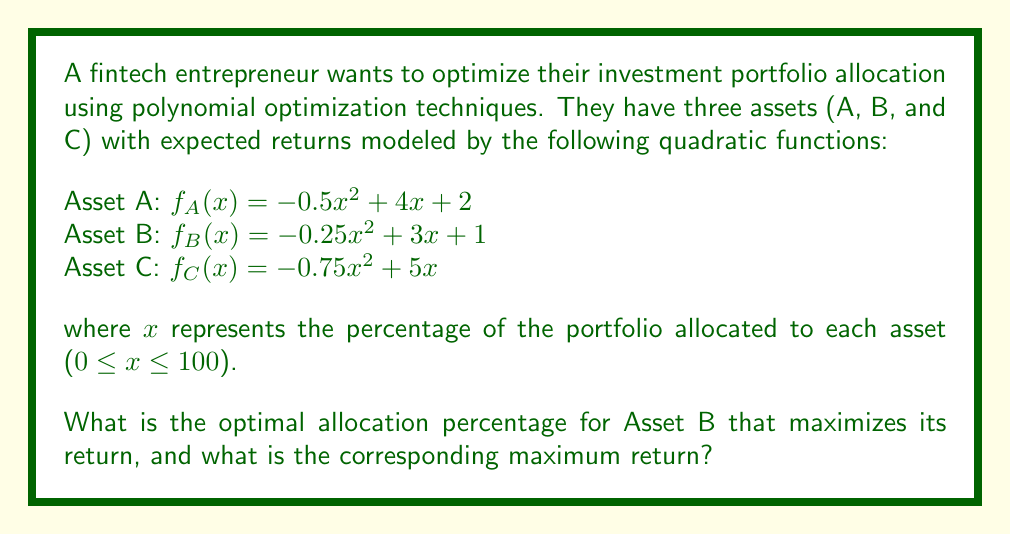Solve this math problem. To find the optimal allocation percentage for Asset B and its maximum return, we need to follow these steps:

1. Identify the quadratic function for Asset B:
   $f_B(x) = -0.25x^2 + 3x + 1$

2. Find the vertex of the parabola, which represents the maximum point:
   For a quadratic function in the form $f(x) = ax^2 + bx + c$, the x-coordinate of the vertex is given by $x = -\frac{b}{2a}$.

   $a = -0.25$
   $b = 3$

   $x = -\frac{3}{2(-0.25)} = -\frac{3}{-0.5} = 6$

3. Calculate the maximum return by plugging x = 6 into the original function:
   $f_B(6) = -0.25(6)^2 + 3(6) + 1$
   $= -0.25(36) + 18 + 1$
   $= -9 + 18 + 1$
   $= 10$

4. Verify that the allocation percentage is within the valid range (0 ≤ x ≤ 100):
   The optimal allocation of 6% is indeed within the valid range.

Therefore, the optimal allocation percentage for Asset B is 6%, and the corresponding maximum return is 10.
Answer: 6%, 10 